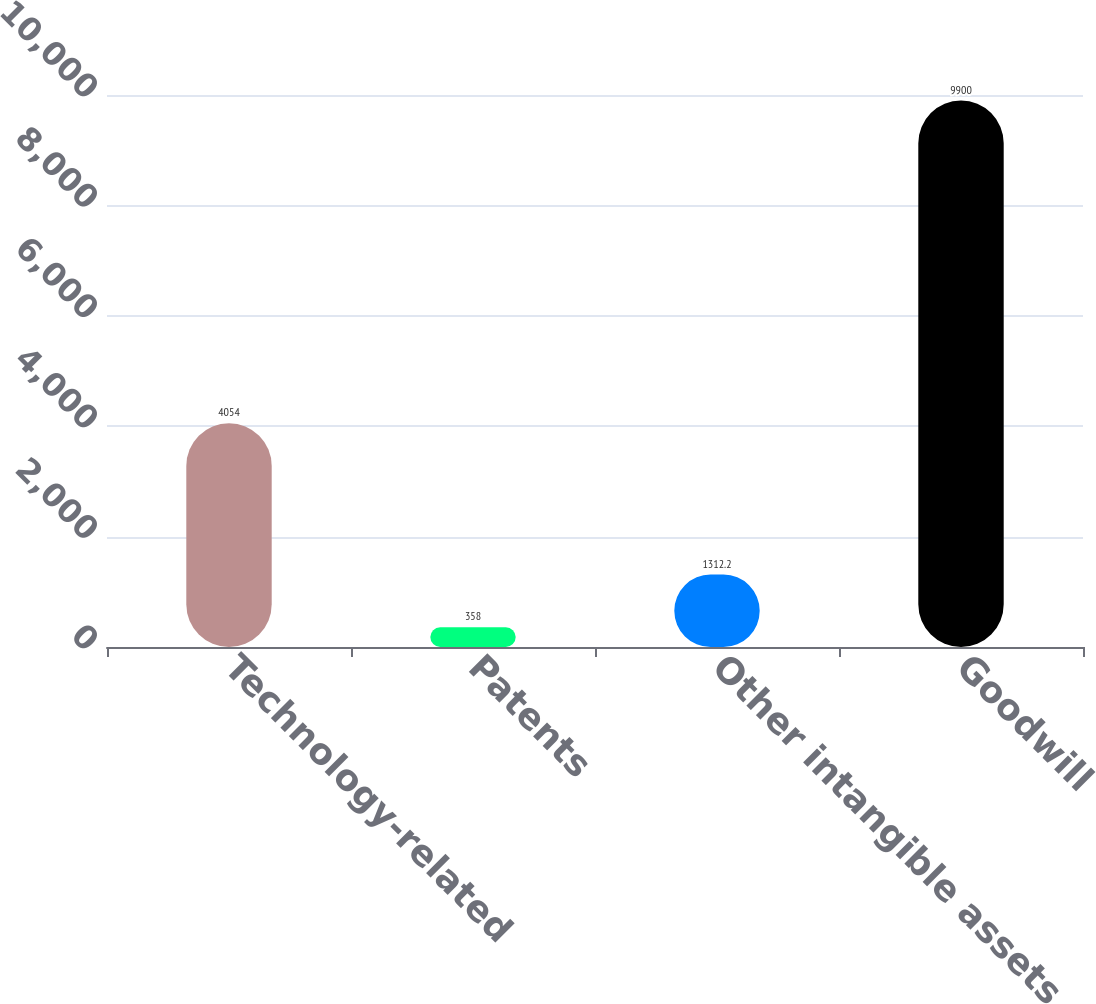Convert chart. <chart><loc_0><loc_0><loc_500><loc_500><bar_chart><fcel>Technology-related<fcel>Patents<fcel>Other intangible assets<fcel>Goodwill<nl><fcel>4054<fcel>358<fcel>1312.2<fcel>9900<nl></chart> 